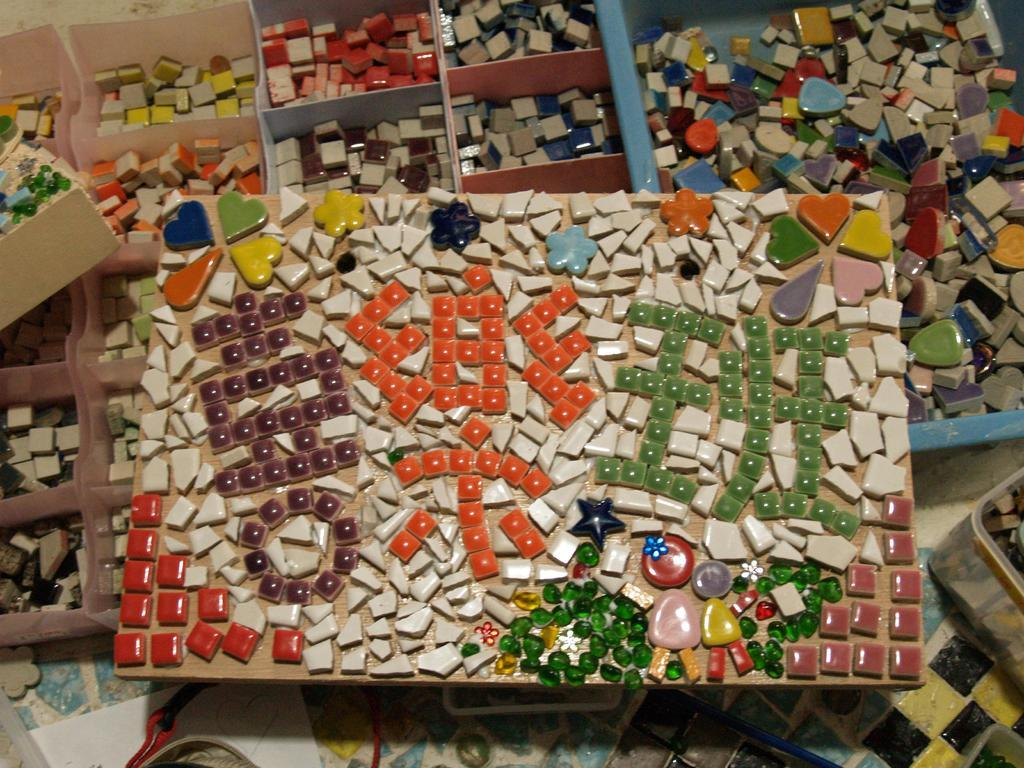What objects are present in the image? There are puzzle pieces in the image. Can you describe the appearance of the puzzle pieces? The puzzle pieces are in different colors. Where is the table located in the image? There is no table present in the image; it only features puzzle pieces. What type of bean is visible in the image? There are no beans present in the image; it only features puzzle pieces. 